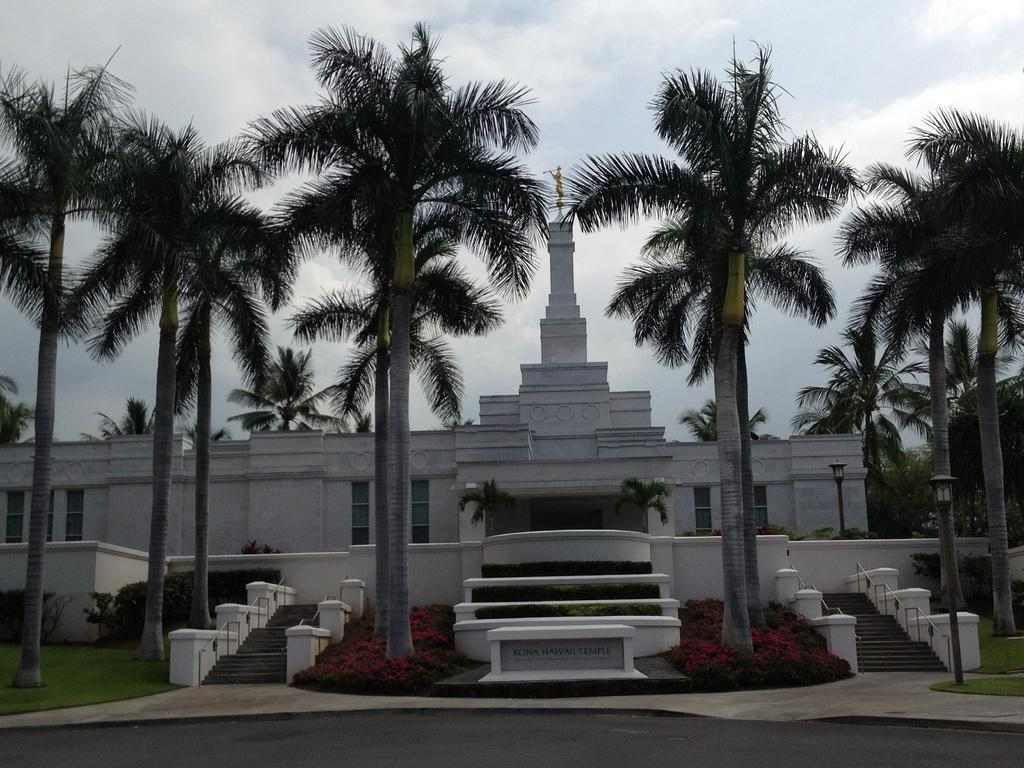What type of structure is present in the image? There is a building in the image. What features can be observed on the building? The building has windows and stairs. What type of vegetation is visible in the image? There are trees and plants in the image. What can be seen in the sky in the image? The sky is visible in the image. Is there any text present in the image? Yes, there is text at the bottom of the image. What type of iron is being used to sort the jelly in the image? There is no iron or jelly present in the image; it features a building with windows and stairs, trees and plants, and text at the bottom. 